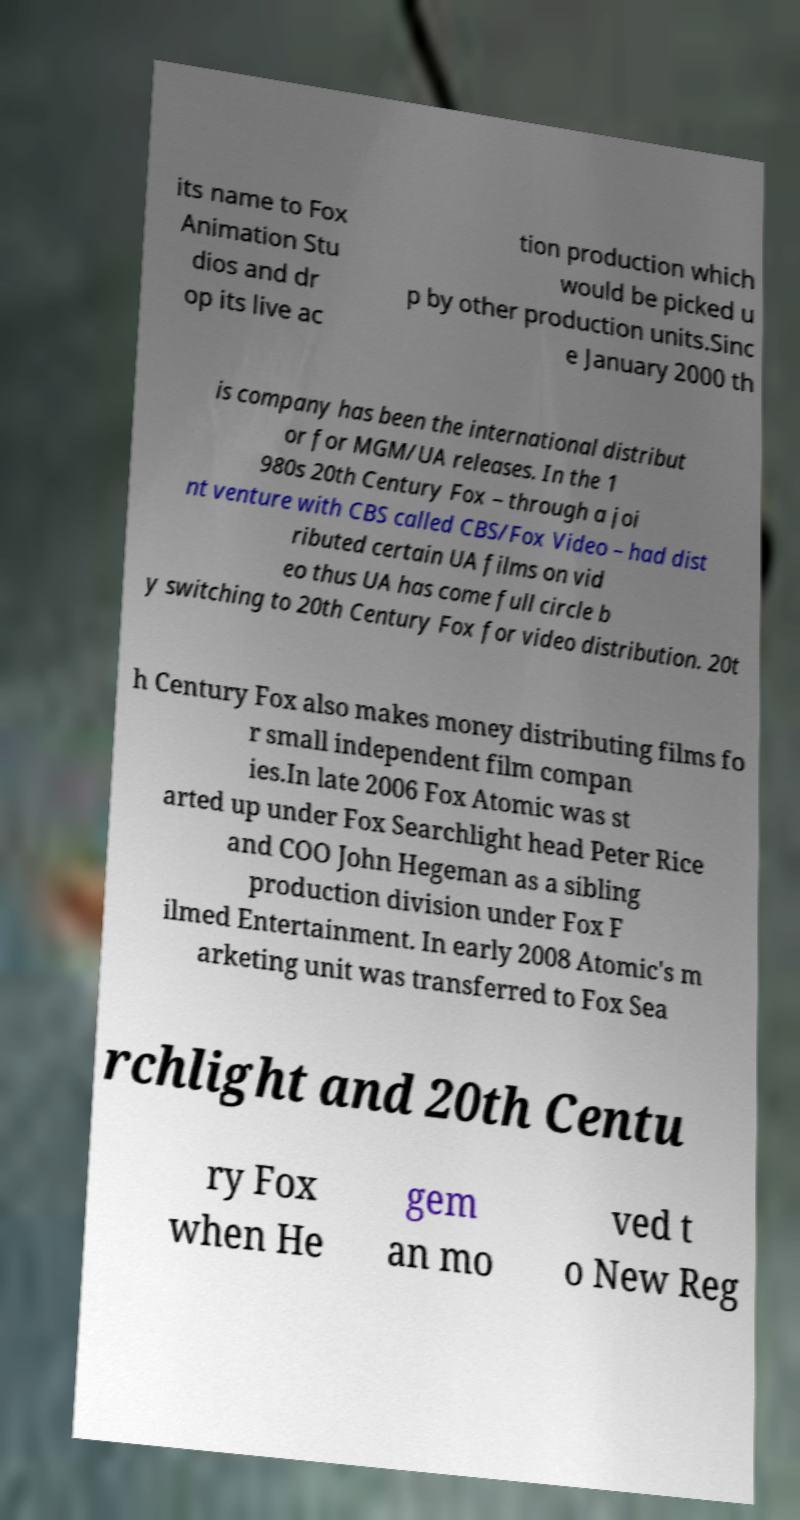Please read and relay the text visible in this image. What does it say? its name to Fox Animation Stu dios and dr op its live ac tion production which would be picked u p by other production units.Sinc e January 2000 th is company has been the international distribut or for MGM/UA releases. In the 1 980s 20th Century Fox – through a joi nt venture with CBS called CBS/Fox Video – had dist ributed certain UA films on vid eo thus UA has come full circle b y switching to 20th Century Fox for video distribution. 20t h Century Fox also makes money distributing films fo r small independent film compan ies.In late 2006 Fox Atomic was st arted up under Fox Searchlight head Peter Rice and COO John Hegeman as a sibling production division under Fox F ilmed Entertainment. In early 2008 Atomic's m arketing unit was transferred to Fox Sea rchlight and 20th Centu ry Fox when He gem an mo ved t o New Reg 